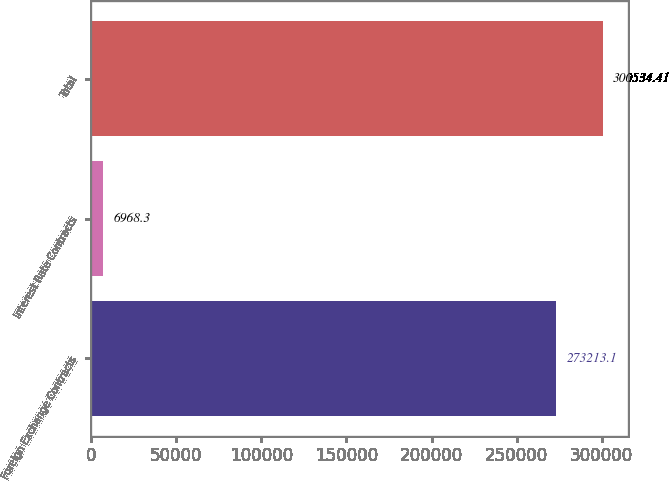Convert chart to OTSL. <chart><loc_0><loc_0><loc_500><loc_500><bar_chart><fcel>Foreign Exchange Contracts<fcel>Interest Rate Contracts<fcel>Total<nl><fcel>273213<fcel>6968.3<fcel>300534<nl></chart> 